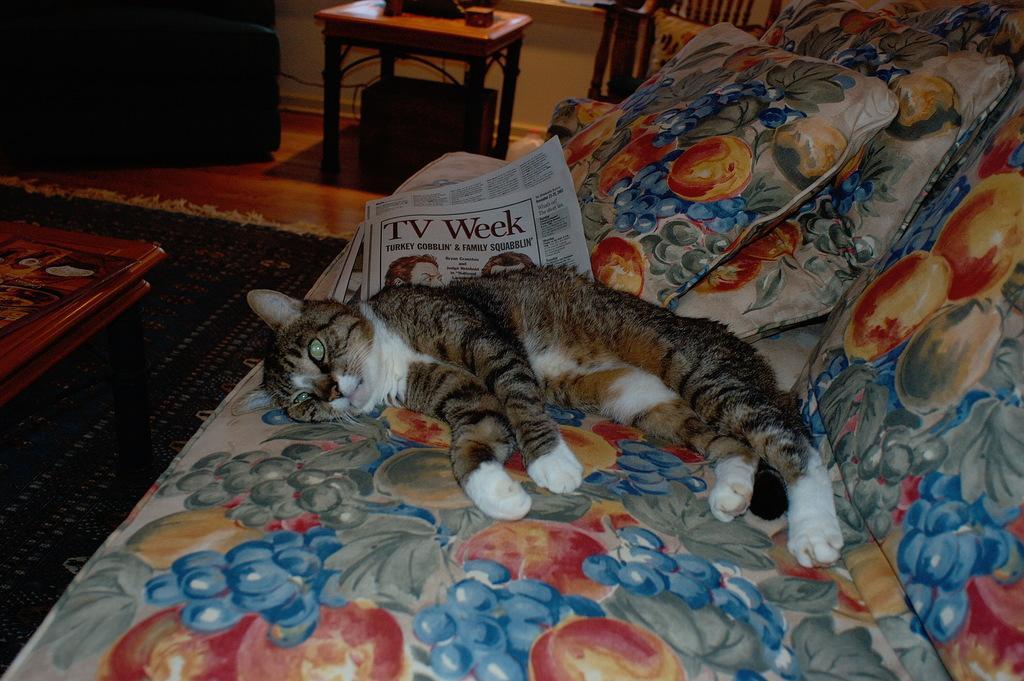How would you summarize this image in a sentence or two? In the image there is a cat slept on the sofa and it seems to be a living room. 